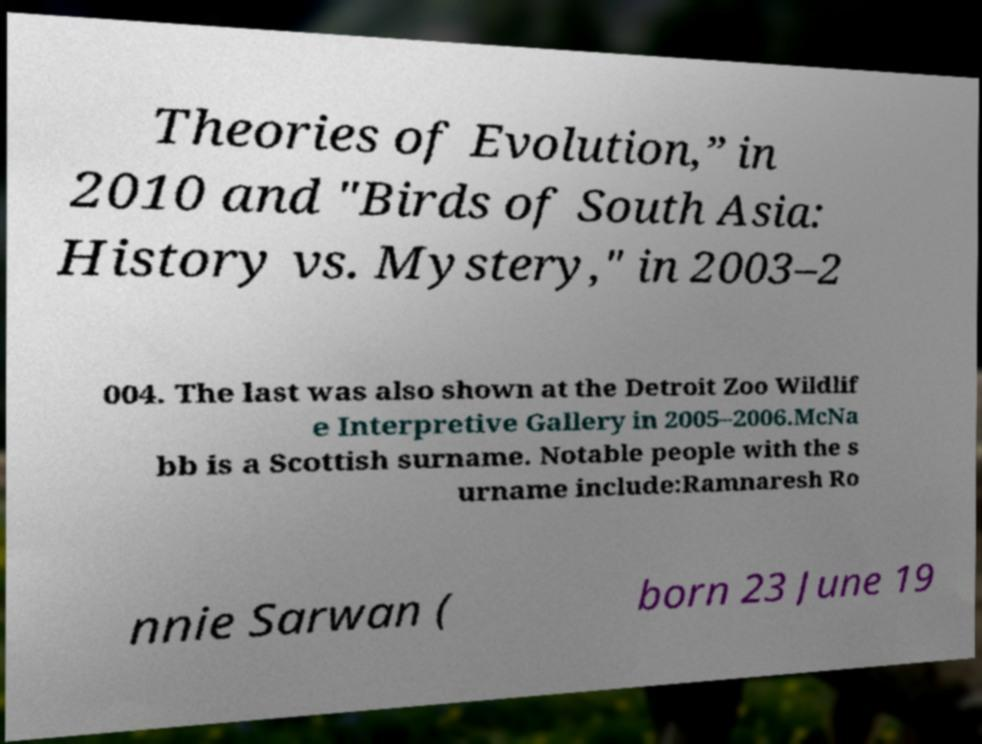Could you assist in decoding the text presented in this image and type it out clearly? Theories of Evolution,” in 2010 and "Birds of South Asia: History vs. Mystery," in 2003–2 004. The last was also shown at the Detroit Zoo Wildlif e Interpretive Gallery in 2005–2006.McNa bb is a Scottish surname. Notable people with the s urname include:Ramnaresh Ro nnie Sarwan ( born 23 June 19 